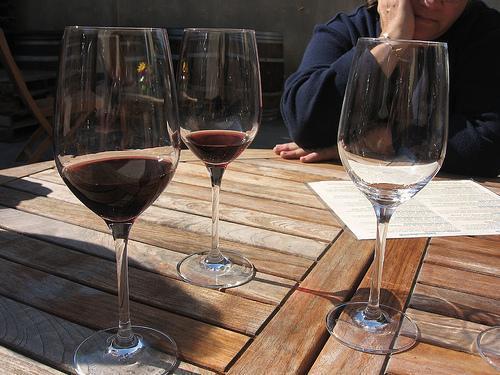How many of the wine glasses have liquid in them?
Give a very brief answer. 2. How many glasses on the table are empty?
Give a very brief answer. 1. How many empty wine glasses are in the image?
Give a very brief answer. 1. How many wine glasses hold dark red wine?
Give a very brief answer. 2. 